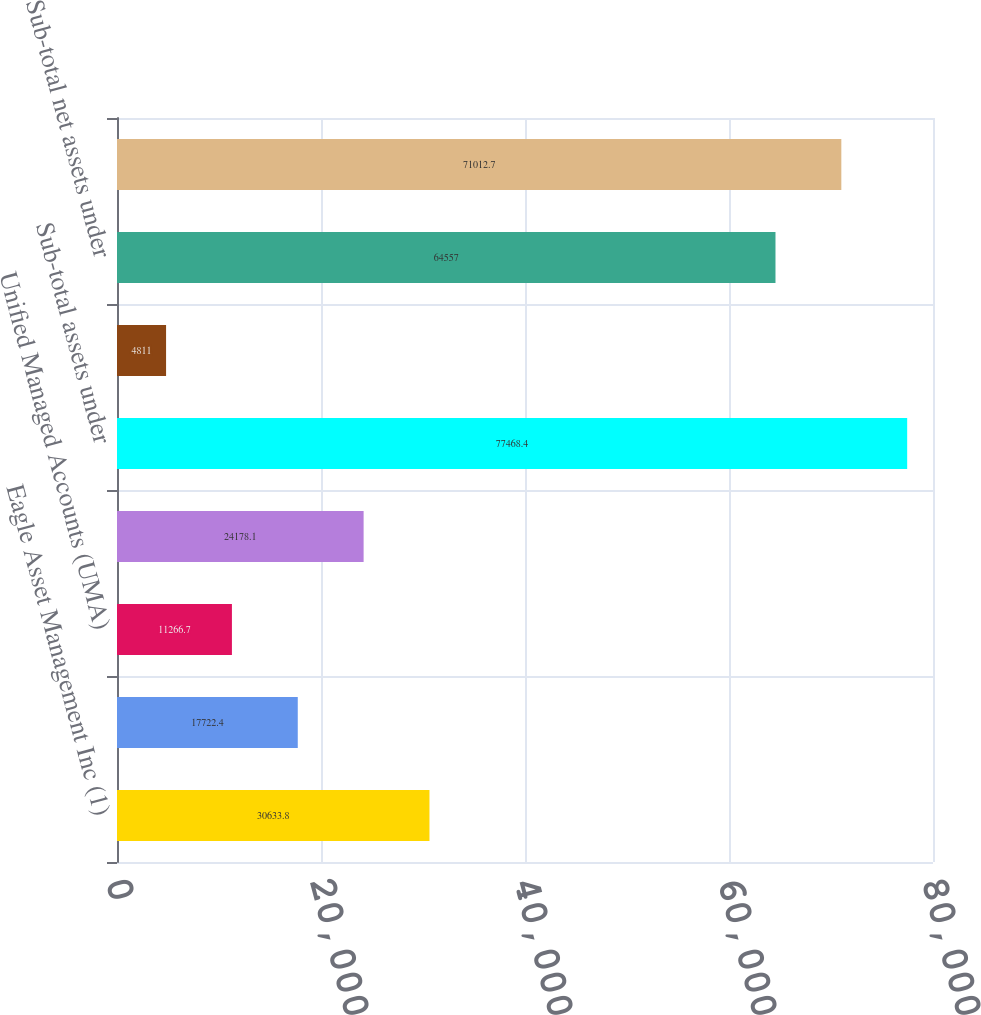Convert chart to OTSL. <chart><loc_0><loc_0><loc_500><loc_500><bar_chart><fcel>Eagle Asset Management Inc (1)<fcel>Raymond James Consulting<fcel>Unified Managed Accounts (UMA)<fcel>Freedom Accounts & other<fcel>Sub-total assets under<fcel>Less Assets managed for<fcel>Sub-total net assets under<fcel>Total financial assets under<nl><fcel>30633.8<fcel>17722.4<fcel>11266.7<fcel>24178.1<fcel>77468.4<fcel>4811<fcel>64557<fcel>71012.7<nl></chart> 